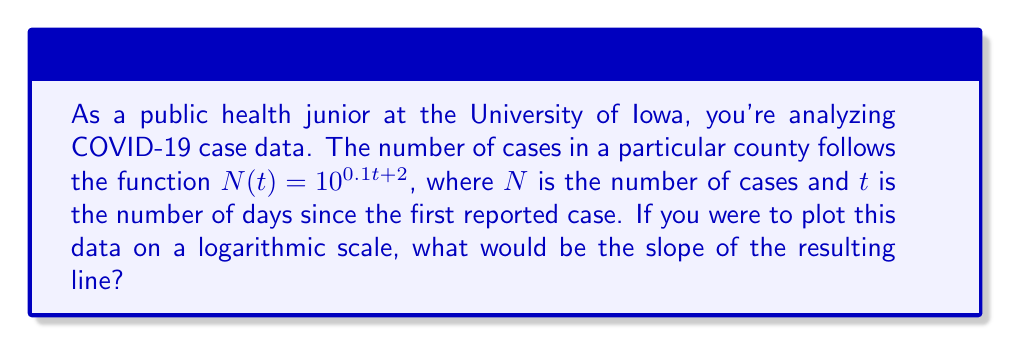Could you help me with this problem? To solve this problem, we need to understand how logarithmic scales work and how they relate to exponential functions. Let's break it down step-by-step:

1) The given function is $N(t) = 10^{0.1t + 2}$

2) To plot this on a logarithmic scale, we take the log of both sides:

   $\log N(t) = \log(10^{0.1t + 2})$

3) Using the logarithm property $\log(a^b) = b\log(a)$, we get:

   $\log N(t) = (0.1t + 2)\log(10)$

4) Since $\log(10) = 1$ (in base 10), this simplifies to:

   $\log N(t) = 0.1t + 2$

5) This is now in the form of a linear equation: $y = mx + b$

   Where:
   $y = \log N(t)$
   $x = t$
   $m = 0.1$ (the slope)
   $b = 2$ (the y-intercept)

6) On a log scale, the slope of the line is the coefficient of $t$, which is 0.1.

This slope represents the rate of exponential growth. A slope of 0.1 means that for every unit increase in $t$, $\log N(t)$ increases by 0.1, or equivalently, $N(t)$ multiplies by $10^{0.1} \approx 1.26$ (an increase of about 26%).
Answer: The slope of the line on the logarithmic scale is 0.1. 